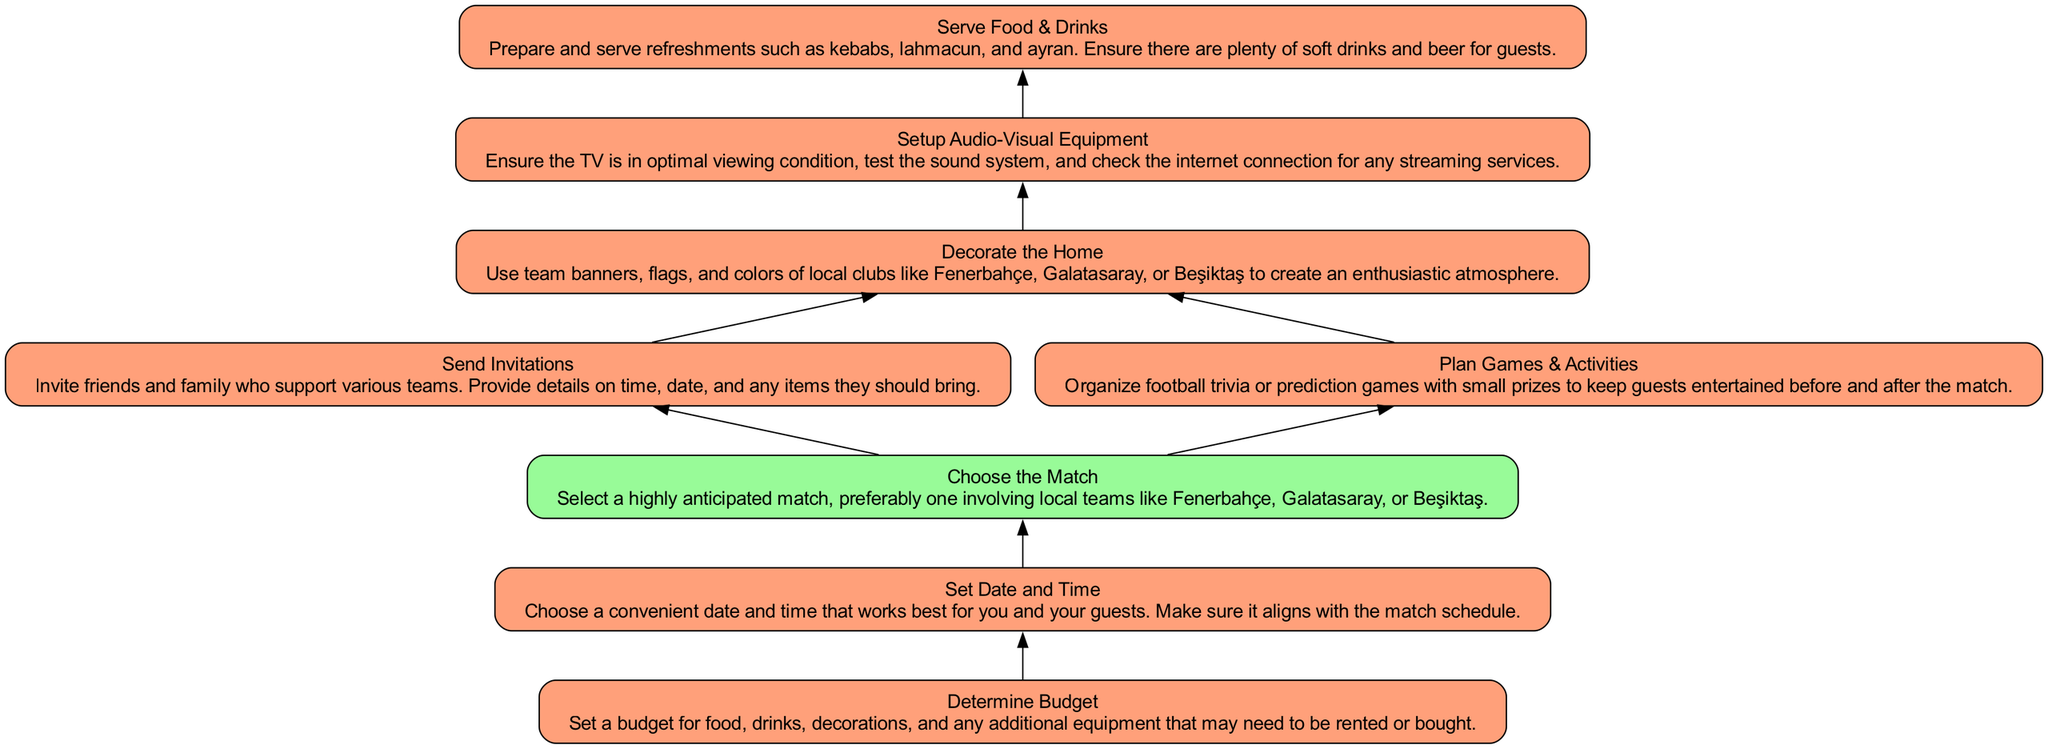What is the first action listed in the diagram? The first action at the bottom of the diagram is "Determine Budget." This is identified as the starting point and is the first node from which subsequent actions flow.
Answer: Determine Budget How many actions are in the diagram? By counting the nodes that are categorized as actions, we find there are 7 actions in total: Determine Budget, Set Date and Time, Choose the Match, Send Invitations, Decorate the Home, Setup Audio-Visual Equipment, and Serve Food & Drinks.
Answer: 7 What comes right after "Choose the Match"? Following "Choose the Match," the next node in the flow is "Send Invitations." This indicates the order of tasks that flow from selecting the match to inviting guests.
Answer: Send Invitations What are two actions that lead to "Decorate the Home"? The two actions leading to "Decorate the Home" are "Send Invitations" and "Plan Games & Activities." This can be seen as both these actions are necessary before proceeding to decorating the home.
Answer: Send Invitations, Plan Games & Activities If the match chosen is not local, which node would be affected? If a non-local match is chosen, the "Choose the Match" decision node would be directly affected as it pertains to the selection of a match. This would necessitate reassessing the invitations and activities planned afterwards.
Answer: Choose the Match Which action occurs just before "Serve Food & Drinks"? The action that comes directly before "Serve Food & Drinks" is "Setup Audio-Visual Equipment." This indicates that preparing the viewing area comes right before preparing refreshments.
Answer: Setup Audio-Visual Equipment How many edges connect the actions in the flow? The flow chart has 8 edges connecting the actions, each representing a directed relationship between the actions and decisions in the party organization process.
Answer: 8 What type of decision is represented in the flow? The type of decision is represented by "Choose the Match," which allows for a choice that determines how the flow of the diagram continues. Decisions are points where different paths can be taken based on conditions.
Answer: Choose the Match Which action is completed after "Plan Games & Activities"? After "Plan Games & Activities," the next action completed is "Decorate the Home." This shows that planning activities is part of the preparations before getting the decoration done.
Answer: Decorate the Home 